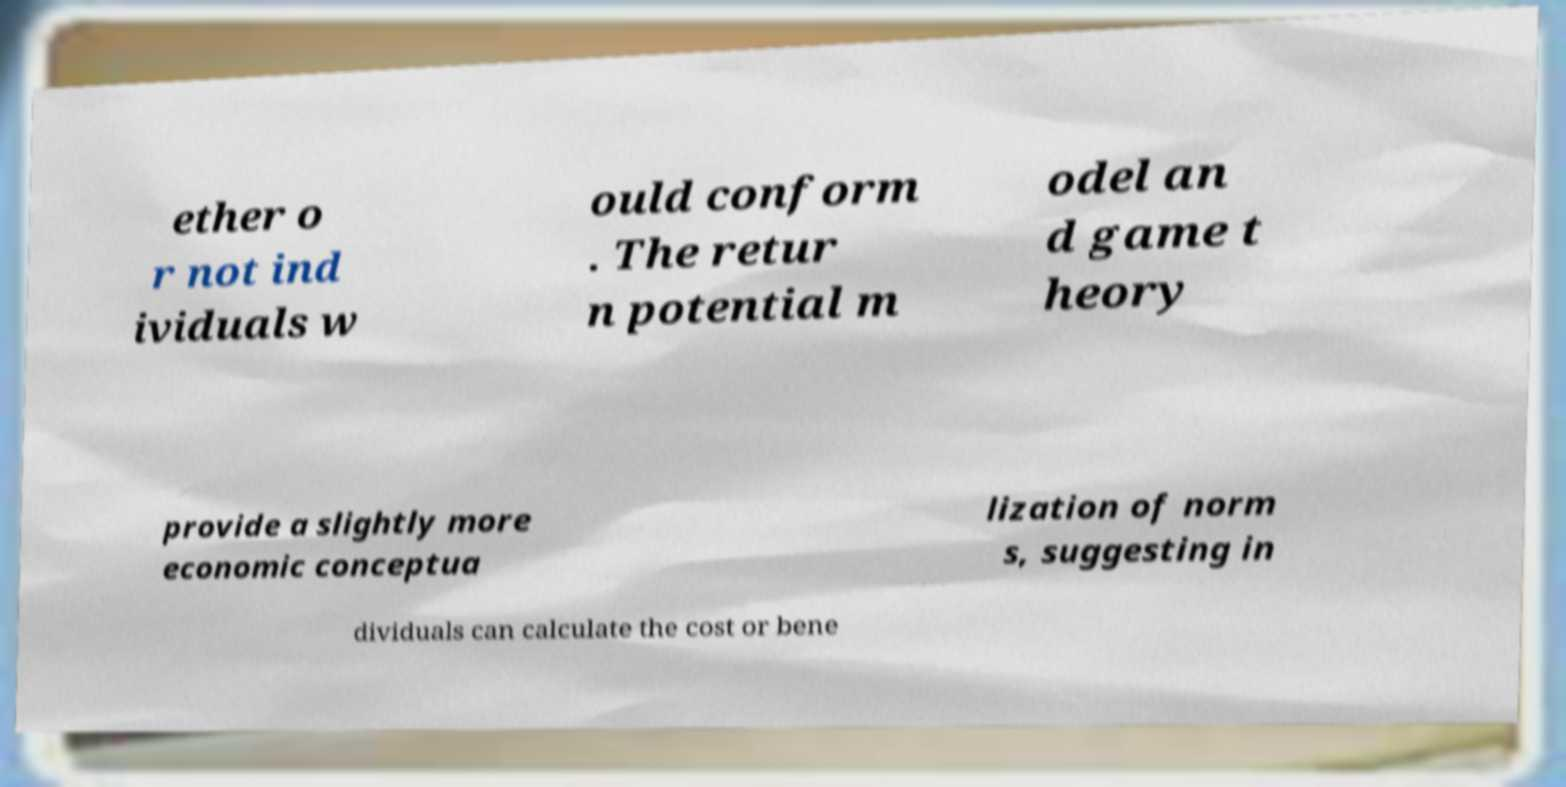There's text embedded in this image that I need extracted. Can you transcribe it verbatim? ether o r not ind ividuals w ould conform . The retur n potential m odel an d game t heory provide a slightly more economic conceptua lization of norm s, suggesting in dividuals can calculate the cost or bene 